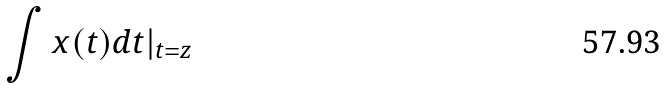Convert formula to latex. <formula><loc_0><loc_0><loc_500><loc_500>\int x ( t ) d t | _ { t = z }</formula> 